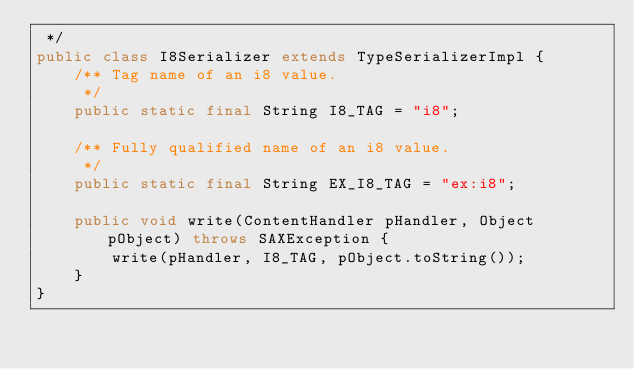Convert code to text. <code><loc_0><loc_0><loc_500><loc_500><_Java_> */
public class I8Serializer extends TypeSerializerImpl {
	/** Tag name of an i8 value.
	 */
	public static final String I8_TAG = "i8";

	/** Fully qualified name of an i8 value.
	 */
	public static final String EX_I8_TAG = "ex:i8";

	public void write(ContentHandler pHandler, Object pObject) throws SAXException {
		write(pHandler, I8_TAG, pObject.toString());
	}
}
</code> 